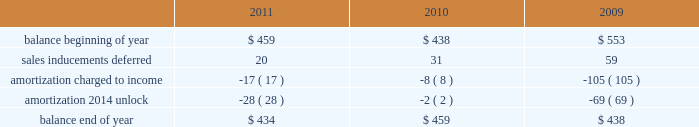The hartford financial services group , inc .
Notes to consolidated financial statements ( continued ) 10 .
Sales inducements accounting policy the company currently offers enhanced crediting rates or bonus payments to contract holders on certain of its individual and group annuity products .
The expense associated with offering a bonus is deferred and amortized over the life of the related contract in a pattern consistent with the amortization of deferred policy acquisition costs .
Amortization expense associated with expenses previously deferred is recorded over the remaining life of the contract .
Consistent with the unlock , the company unlocked the amortization of the sales inducement asset .
See note 7 for more information concerning the unlock .
Changes in deferred sales inducement activity were as follows for the years ended december 31: .
11 .
Reserves for future policy benefits and unpaid losses and loss adjustment expenses life insurance products accounting policy liabilities for future policy benefits are calculated by the net level premium method using interest , withdrawal and mortality assumptions appropriate at the time the policies were issued .
The methods used in determining the liability for unpaid losses and future policy benefits are standard actuarial methods recognized by the american academy of actuaries .
For the tabular reserves , discount rates are based on the company 2019s earned investment yield and the morbidity/mortality tables used are standard industry tables modified to reflect the company 2019s actual experience when appropriate .
In particular , for the company 2019s group disability known claim reserves , the morbidity table for the early durations of claim is based exclusively on the company 2019s experience , incorporating factors such as gender , elimination period and diagnosis .
These reserves are computed such that they are expected to meet the company 2019s future policy obligations .
Future policy benefits are computed at amounts that , with additions from estimated premiums to be received and with interest on such reserves compounded annually at certain assumed rates , are expected to be sufficient to meet the company 2019s policy obligations at their maturities or in the event of an insured 2019s death .
Changes in or deviations from the assumptions used for mortality , morbidity , expected future premiums and interest can significantly affect the company 2019s reserve levels and related future operations and , as such , provisions for adverse deviation are built into the long-tailed liability assumptions .
Liabilities for the company 2019s group life and disability contracts , as well as its individual term life insurance policies , include amounts for unpaid losses and future policy benefits .
Liabilities for unpaid losses include estimates of amounts to fully settle known reported claims , as well as claims related to insured events that the company estimates have been incurred but have not yet been reported .
These reserve estimates are based on known facts and interpretations of circumstances , and consideration of various internal factors including the hartford 2019s experience with similar cases , historical trends involving claim payment patterns , loss payments , pending levels of unpaid claims , loss control programs and product mix .
In addition , the reserve estimates are influenced by consideration of various external factors including court decisions , economic conditions and public attitudes .
The effects of inflation are implicitly considered in the reserving process. .
What is the net change in the balance of deferred sales in 2010? 
Computations: (459 - 438)
Answer: 21.0. 